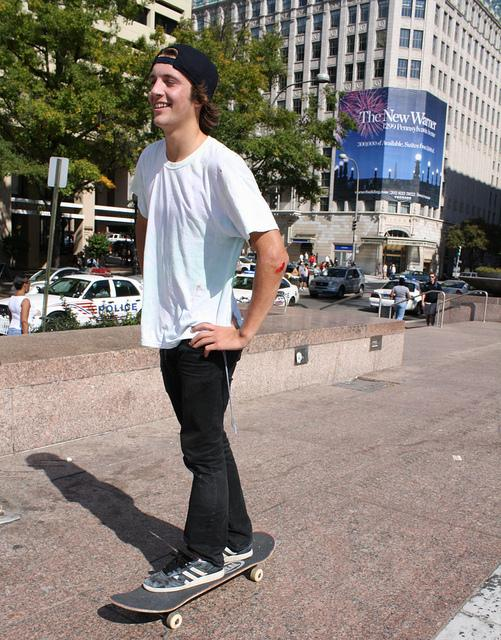What type of shoes is the boy wearing? skateboarding 